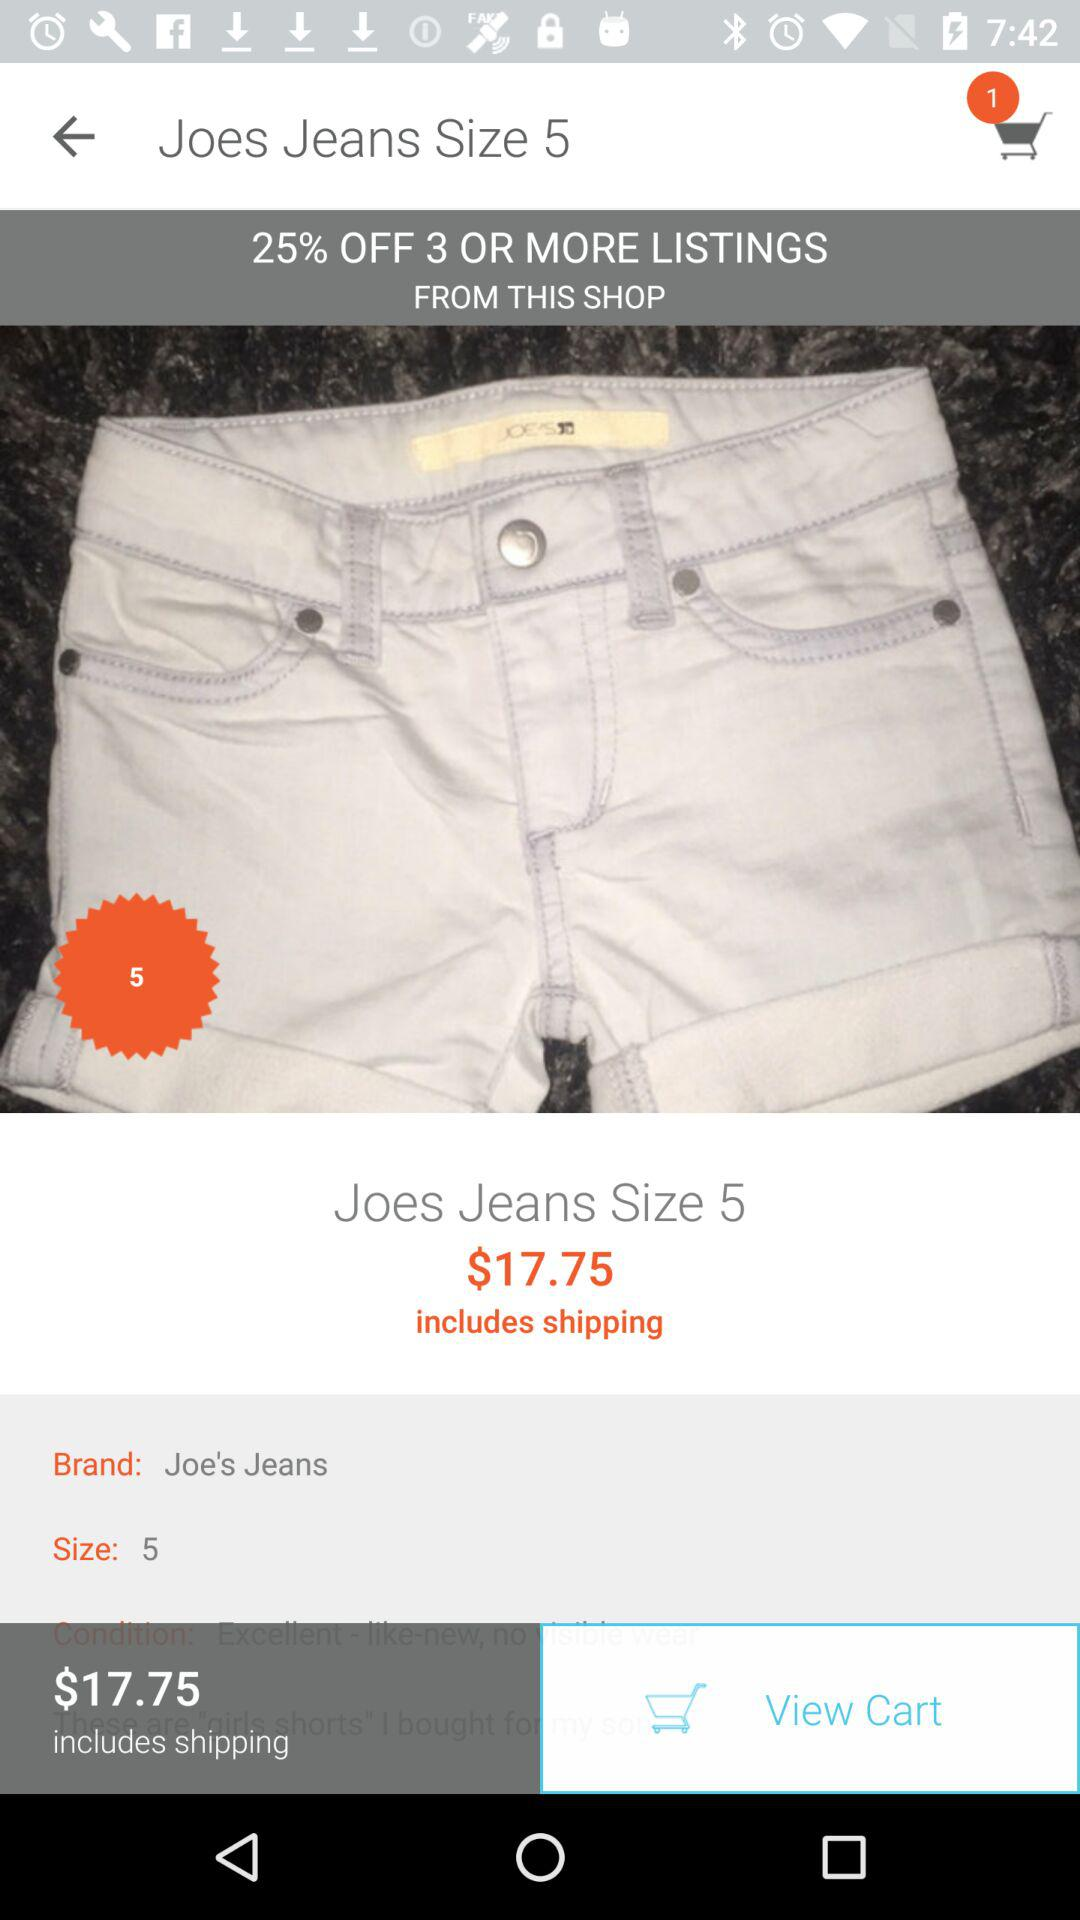What's the Joes Jeans size? The Joes Jeans size is 5. 